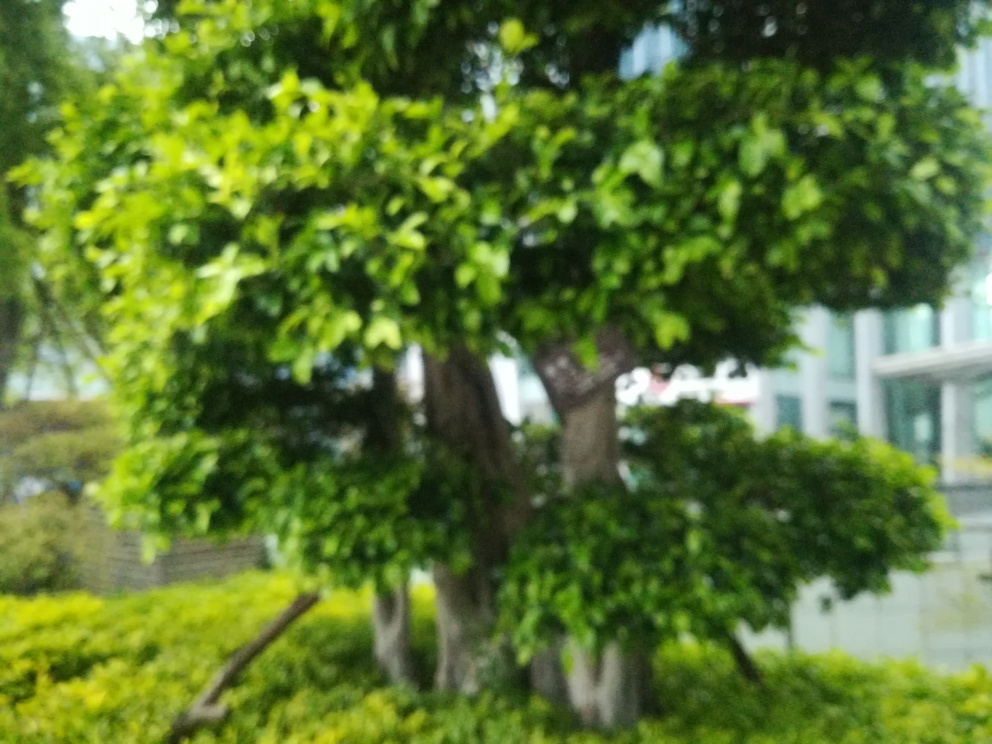What changes could improve the clarity of a photo like this? Improvements could include using a faster shutter speed to eliminate camera shake, adjusting the focus to the correct distance, cleaning the lens, or using image stabilization features if available. 